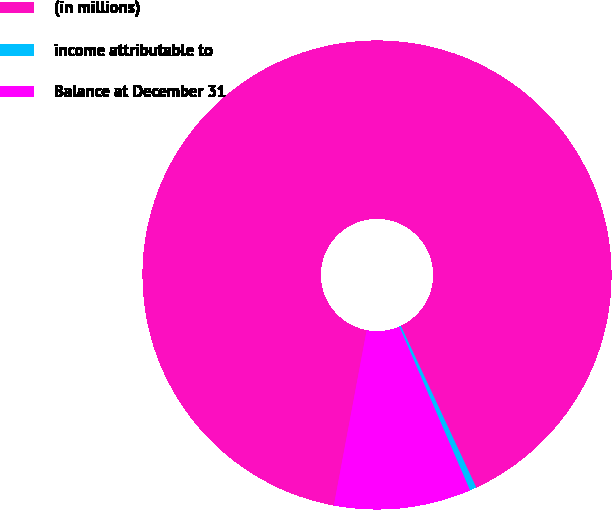Convert chart. <chart><loc_0><loc_0><loc_500><loc_500><pie_chart><fcel>(in millions)<fcel>income attributable to<fcel>Balance at December 31<nl><fcel>90.1%<fcel>0.47%<fcel>9.43%<nl></chart> 